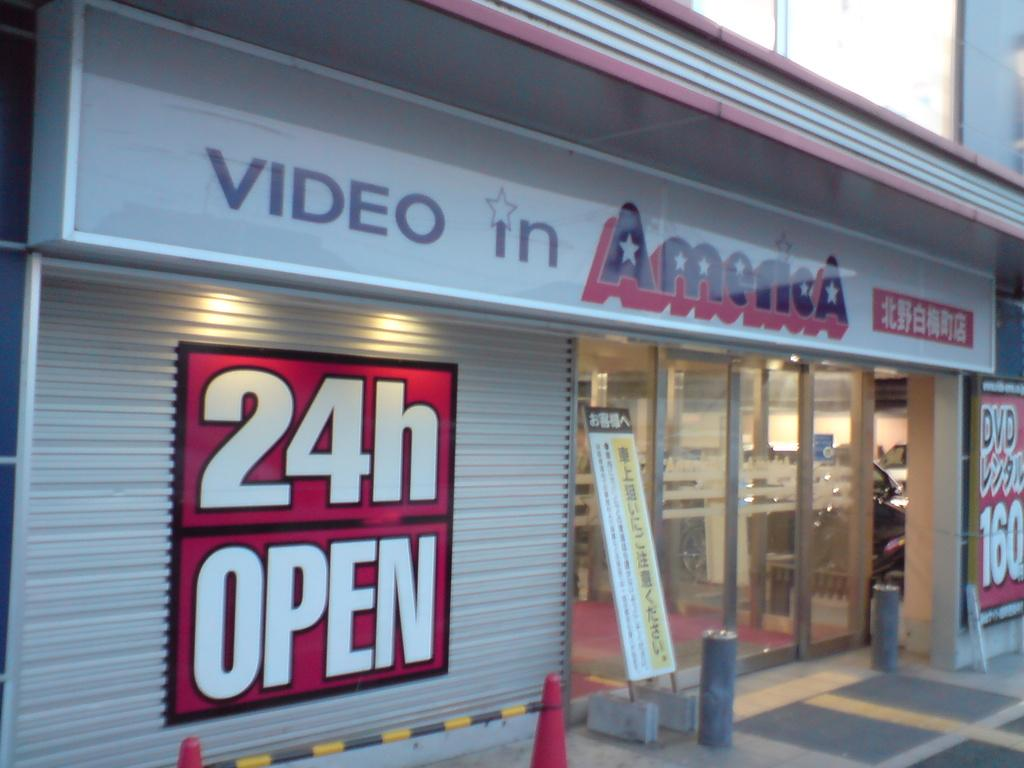What type of establishment is shown in the image? There is a store in the image. What objects can be seen near the store? Boards and traffic cones are visible in the image. What type of straw is being used to start a record in the image? There is no straw, start, or record present in the image. 